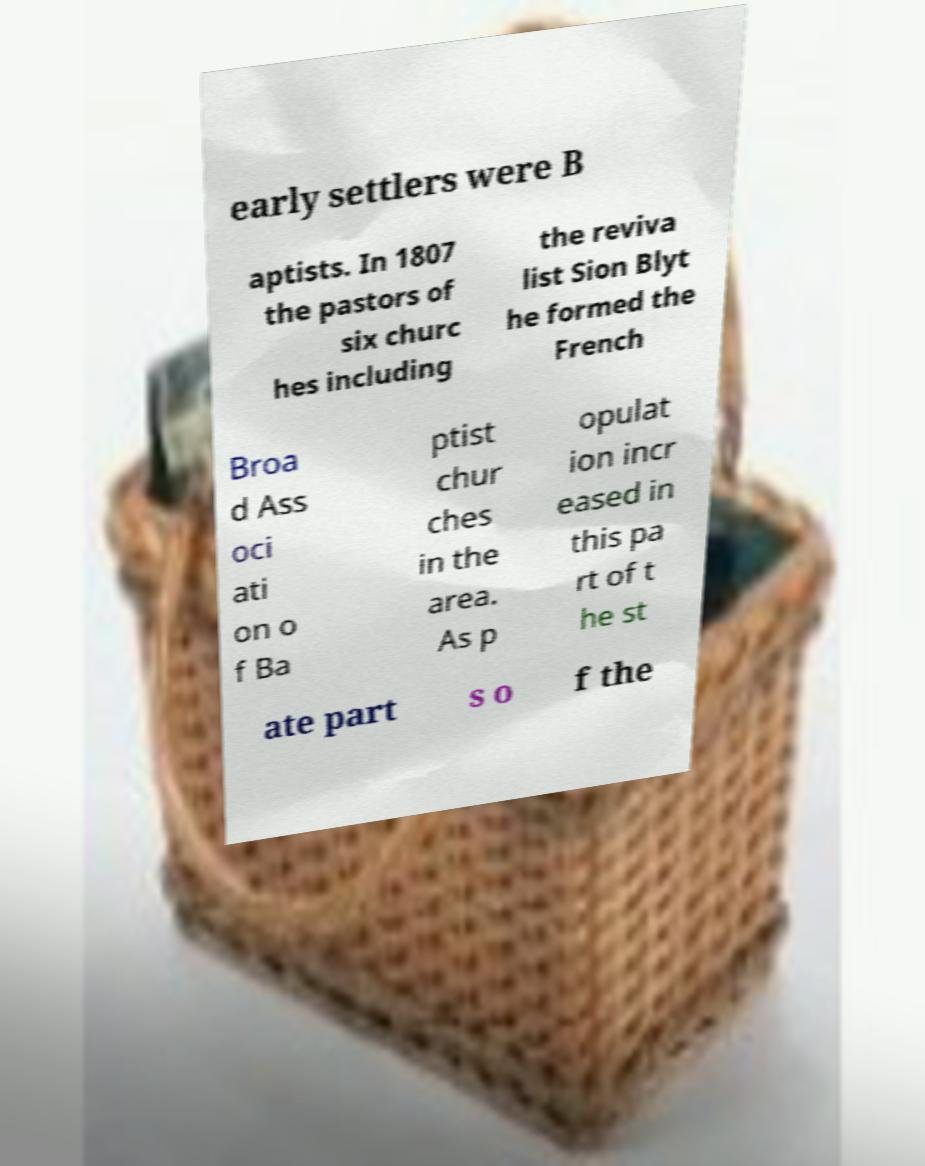Could you assist in decoding the text presented in this image and type it out clearly? early settlers were B aptists. In 1807 the pastors of six churc hes including the reviva list Sion Blyt he formed the French Broa d Ass oci ati on o f Ba ptist chur ches in the area. As p opulat ion incr eased in this pa rt of t he st ate part s o f the 